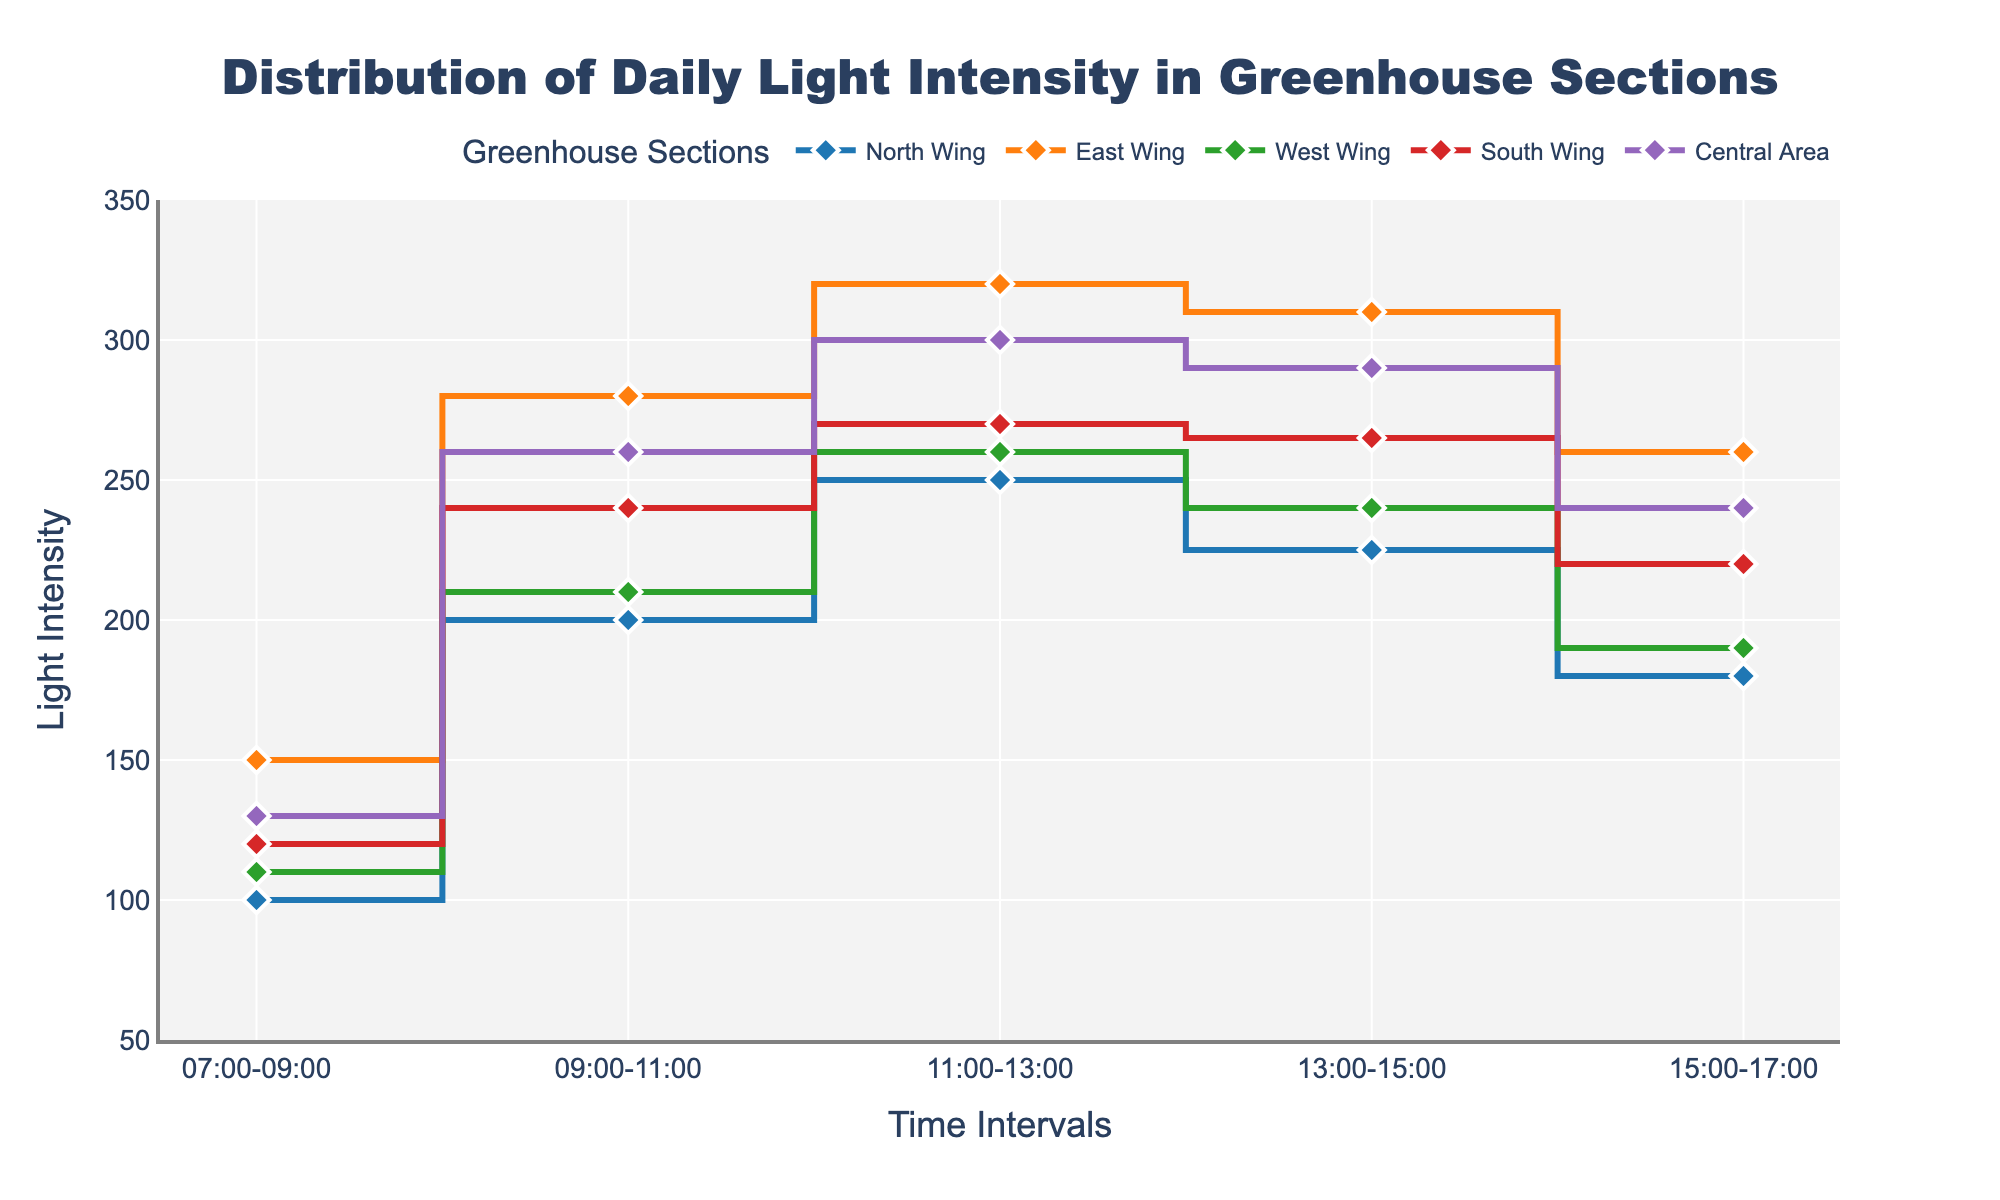What's the title of the figure? The title of the figure is written at the top center of the plot. By reading it, we can identify the title as "Distribution of Daily Light Intensity in Greenhouse Sections."
Answer: Distribution of Daily Light Intensity in Greenhouse Sections How many time intervals are shown in the plot? By examining the x-axis, we can see that there are five distinct time intervals labeled: 07:00-09:00, 09:00-11:00, 11:00-13:00, 13:00-15:00, and 15:00-17:00.
Answer: Five Which greenhouse section has the highest light intensity at 11:00-13:00? Observe the y-values of each section at the time interval 11:00-13:00. The East Wing has the highest value, at 320.
Answer: East Wing Which section shows a decrease in light intensity from 09:00-11:00 to 11:00-13:00? Look at the y-values between 09:00-11:00 and 11:00-13:00 for each section. The North Wing (200 to 250), East Wing (280 to 320), West Wing (210 to 260), South Wing (240 to 270), and Central Area (260 to 300) all show an increase; thus, none show a decrease in this interval.
Answer: None What's the average light intensity for the Central Area throughout the day? Sum the values for the Central Area (130 + 260 + 300 + 290 + 240) = 1220. Then, divide by the number of intervals, which is 5: 1220 / 5 = 244.
Answer: 244 Which greenhouse section has the most significant fluctuation in light intensity? Calculate the range (maximum - minimum) for each section: North Wing (250 - 100 = 150), East Wing (320 - 150 = 170), West Wing (260 - 110 = 150), South Wing (270 - 120 = 150), Central Area (300 - 130 = 170). Both East Wing and Central Area have the highest fluctuation with 170.
Answer: East Wing and Central Area During which time interval is the light intensity the highest for the entire greenhouse? Identify the maximum light intensity for each interval across all sections: 07:00-09:00 (150), 09:00-11:00 (280), 11:00-13:00 (320), 13:00-15:00 (310), 15:00-17:00 (260). The maximum value is 320, during 11:00-13:00.
Answer: 11:00-13:00 Which section has the smallest increase in light intensity between 07:00-09:00 and 09:00-11:00? Calculate the increase for each section: North Wing (200 - 100 = 100), East Wing (280 - 150 = 130), West Wing (210 - 110 = 100), South Wing (240 - 120 = 120), Central Area (260 - 130 = 130). Both North Wing and West Wing have the smallest increase of 100.
Answer: North Wing and West Wing 